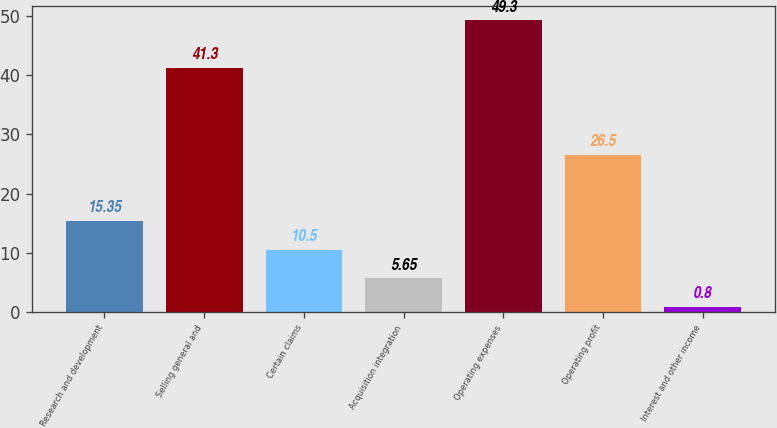<chart> <loc_0><loc_0><loc_500><loc_500><bar_chart><fcel>Research and development<fcel>Selling general and<fcel>Certain claims<fcel>Acquisition integration<fcel>Operating expenses<fcel>Operating profit<fcel>Interest and other income<nl><fcel>15.35<fcel>41.3<fcel>10.5<fcel>5.65<fcel>49.3<fcel>26.5<fcel>0.8<nl></chart> 